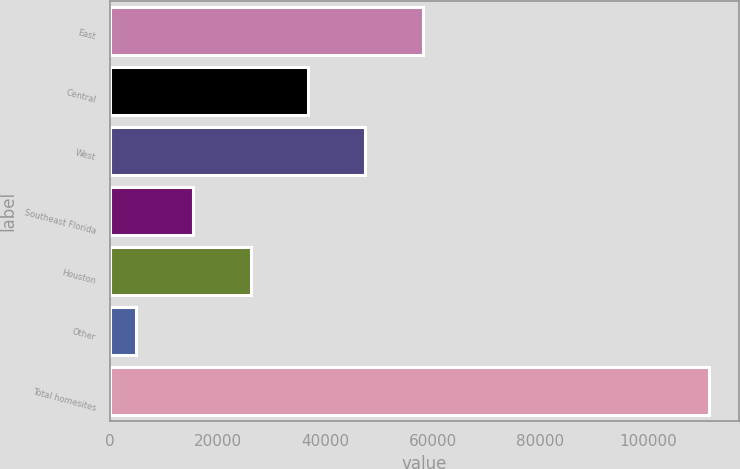Convert chart to OTSL. <chart><loc_0><loc_0><loc_500><loc_500><bar_chart><fcel>East<fcel>Central<fcel>West<fcel>Southeast Florida<fcel>Houston<fcel>Other<fcel>Total homesites<nl><fcel>58124.5<fcel>36819.9<fcel>47472.2<fcel>15515.3<fcel>26167.6<fcel>4863<fcel>111386<nl></chart> 